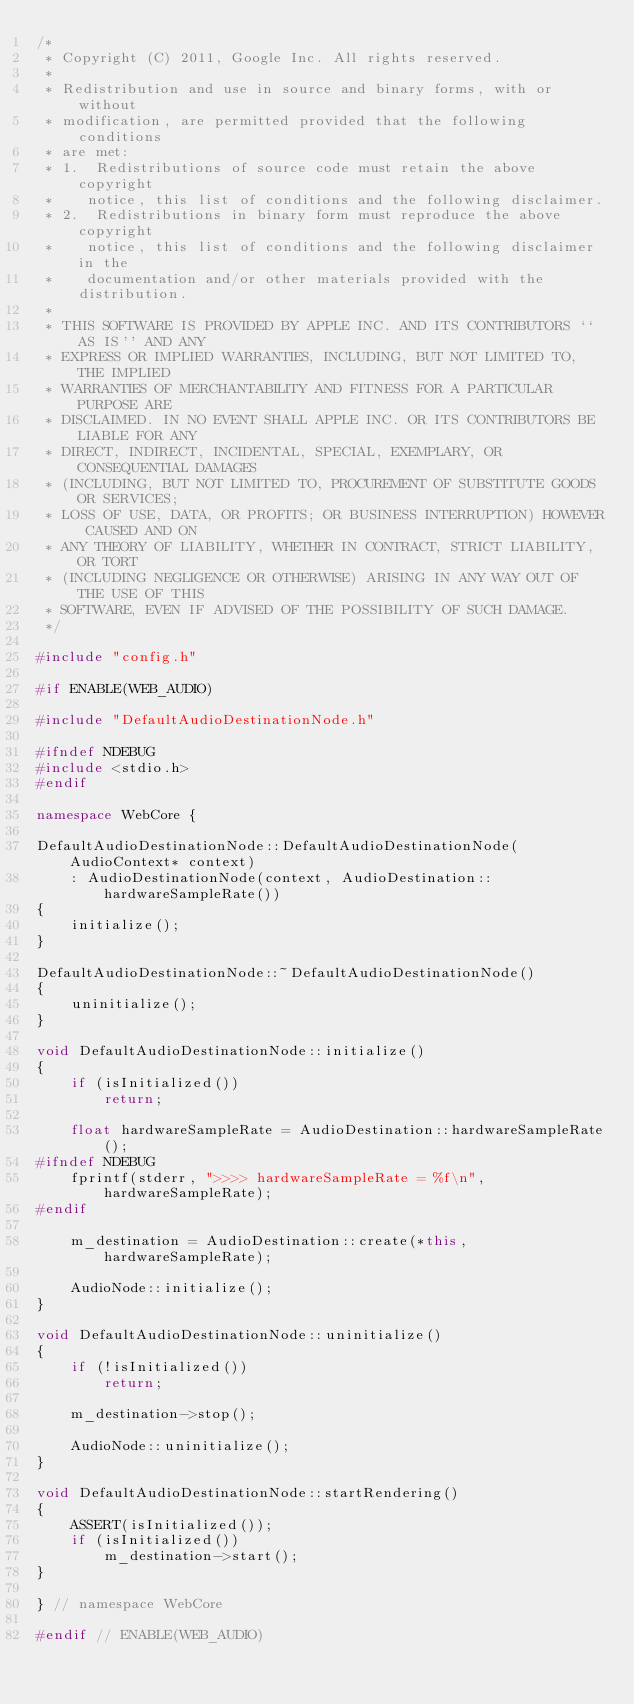<code> <loc_0><loc_0><loc_500><loc_500><_C++_>/*
 * Copyright (C) 2011, Google Inc. All rights reserved.
 *
 * Redistribution and use in source and binary forms, with or without
 * modification, are permitted provided that the following conditions
 * are met:
 * 1.  Redistributions of source code must retain the above copyright
 *    notice, this list of conditions and the following disclaimer.
 * 2.  Redistributions in binary form must reproduce the above copyright
 *    notice, this list of conditions and the following disclaimer in the
 *    documentation and/or other materials provided with the distribution.
 *
 * THIS SOFTWARE IS PROVIDED BY APPLE INC. AND ITS CONTRIBUTORS ``AS IS'' AND ANY
 * EXPRESS OR IMPLIED WARRANTIES, INCLUDING, BUT NOT LIMITED TO, THE IMPLIED
 * WARRANTIES OF MERCHANTABILITY AND FITNESS FOR A PARTICULAR PURPOSE ARE
 * DISCLAIMED. IN NO EVENT SHALL APPLE INC. OR ITS CONTRIBUTORS BE LIABLE FOR ANY
 * DIRECT, INDIRECT, INCIDENTAL, SPECIAL, EXEMPLARY, OR CONSEQUENTIAL DAMAGES
 * (INCLUDING, BUT NOT LIMITED TO, PROCUREMENT OF SUBSTITUTE GOODS OR SERVICES;
 * LOSS OF USE, DATA, OR PROFITS; OR BUSINESS INTERRUPTION) HOWEVER CAUSED AND ON
 * ANY THEORY OF LIABILITY, WHETHER IN CONTRACT, STRICT LIABILITY, OR TORT
 * (INCLUDING NEGLIGENCE OR OTHERWISE) ARISING IN ANY WAY OUT OF THE USE OF THIS
 * SOFTWARE, EVEN IF ADVISED OF THE POSSIBILITY OF SUCH DAMAGE.
 */

#include "config.h"

#if ENABLE(WEB_AUDIO)

#include "DefaultAudioDestinationNode.h"

#ifndef NDEBUG
#include <stdio.h>
#endif

namespace WebCore {
    
DefaultAudioDestinationNode::DefaultAudioDestinationNode(AudioContext* context)
    : AudioDestinationNode(context, AudioDestination::hardwareSampleRate())
{
    initialize();
}

DefaultAudioDestinationNode::~DefaultAudioDestinationNode()
{
    uninitialize();
}

void DefaultAudioDestinationNode::initialize()
{
    if (isInitialized())
        return;

    float hardwareSampleRate = AudioDestination::hardwareSampleRate();
#ifndef NDEBUG    
    fprintf(stderr, ">>>> hardwareSampleRate = %f\n", hardwareSampleRate);
#endif
    
    m_destination = AudioDestination::create(*this, hardwareSampleRate);
    
    AudioNode::initialize();
}

void DefaultAudioDestinationNode::uninitialize()
{
    if (!isInitialized())
        return;

    m_destination->stop();

    AudioNode::uninitialize();
}

void DefaultAudioDestinationNode::startRendering()
{
    ASSERT(isInitialized());
    if (isInitialized())
        m_destination->start();
}

} // namespace WebCore

#endif // ENABLE(WEB_AUDIO)
</code> 